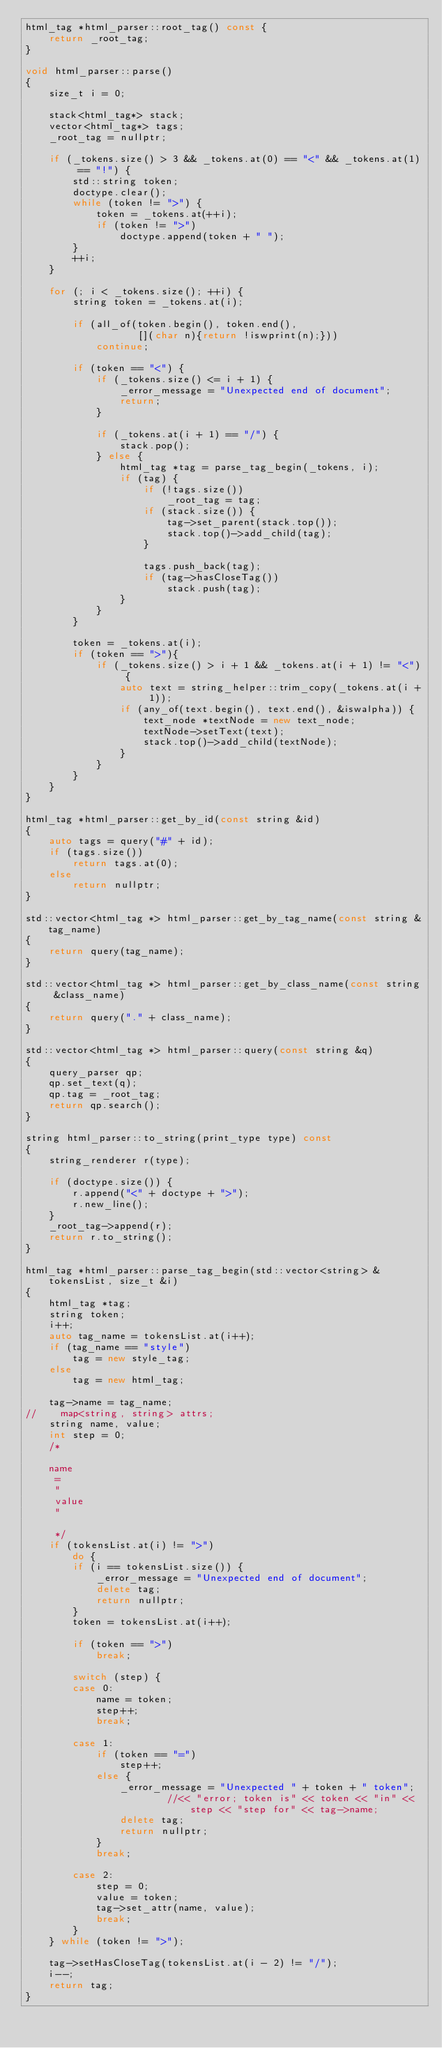<code> <loc_0><loc_0><loc_500><loc_500><_C++_>html_tag *html_parser::root_tag() const {
    return _root_tag;
}

void html_parser::parse()
{
    size_t i = 0;

    stack<html_tag*> stack;
    vector<html_tag*> tags;
    _root_tag = nullptr;

    if (_tokens.size() > 3 && _tokens.at(0) == "<" && _tokens.at(1) == "!") {
        std::string token;
        doctype.clear();
        while (token != ">") {
            token = _tokens.at(++i);
            if (token != ">")
                doctype.append(token + " ");
        }
        ++i;
    }

    for (; i < _tokens.size(); ++i) {
        string token = _tokens.at(i);

        if (all_of(token.begin(), token.end(),
                   [](char n){return !iswprint(n);}))
            continue;

        if (token == "<") {
            if (_tokens.size() <= i + 1) {
                _error_message = "Unexpected end of document";
                return;
            }

            if (_tokens.at(i + 1) == "/") {
                stack.pop();
            } else {
                html_tag *tag = parse_tag_begin(_tokens, i);
                if (tag) {
                    if (!tags.size())
                        _root_tag = tag;
                    if (stack.size()) {
                        tag->set_parent(stack.top());
                        stack.top()->add_child(tag);
                    }

                    tags.push_back(tag);
                    if (tag->hasCloseTag())
                        stack.push(tag);
                }
            }
        }

        token = _tokens.at(i);
        if (token == ">"){
            if (_tokens.size() > i + 1 && _tokens.at(i + 1) != "<") {
                auto text = string_helper::trim_copy(_tokens.at(i + 1));
                if (any_of(text.begin(), text.end(), &iswalpha)) {
                    text_node *textNode = new text_node;
                    textNode->setText(text);
                    stack.top()->add_child(textNode);
                }
            }
        }
    }
}

html_tag *html_parser::get_by_id(const string &id)
{
    auto tags = query("#" + id);
    if (tags.size())
        return tags.at(0);
    else
        return nullptr;
}

std::vector<html_tag *> html_parser::get_by_tag_name(const string &tag_name)
{
    return query(tag_name);
}

std::vector<html_tag *> html_parser::get_by_class_name(const string &class_name)
{
    return query("." + class_name);
}

std::vector<html_tag *> html_parser::query(const string &q)
{
    query_parser qp;
    qp.set_text(q);
    qp.tag = _root_tag;
    return qp.search();
}

string html_parser::to_string(print_type type) const
{
    string_renderer r(type);

    if (doctype.size()) {
        r.append("<" + doctype + ">");
        r.new_line();
    }
    _root_tag->append(r);
    return r.to_string();
}

html_tag *html_parser::parse_tag_begin(std::vector<string> &tokensList, size_t &i)
{
    html_tag *tag;
    string token;
    i++;
    auto tag_name = tokensList.at(i++);
    if (tag_name == "style")
        tag = new style_tag;
    else
        tag = new html_tag;

    tag->name = tag_name;
//    map<string, string> attrs;
    string name, value;
    int step = 0;
    /*

    name
     =
     "
     value
     "

     */
    if (tokensList.at(i) != ">")
        do {
        if (i == tokensList.size()) {
            _error_message = "Unexpected end of document";
            delete tag;
            return nullptr;
        }
        token = tokensList.at(i++);

        if (token == ">")
            break;

        switch (step) {
        case 0:
            name = token;
            step++;
            break;

        case 1:
            if (token == "=")
                step++;
            else {
                _error_message = "Unexpected " + token + " token";
                        //<< "error; token is" << token << "in" << step << "step for" << tag->name;
                delete tag;
                return nullptr;
            }
            break;

        case 2:
            step = 0;
            value = token;
            tag->set_attr(name, value);
            break;
        }
    } while (token != ">");

    tag->setHasCloseTag(tokensList.at(i - 2) != "/");
    i--;
    return tag;
}
</code> 